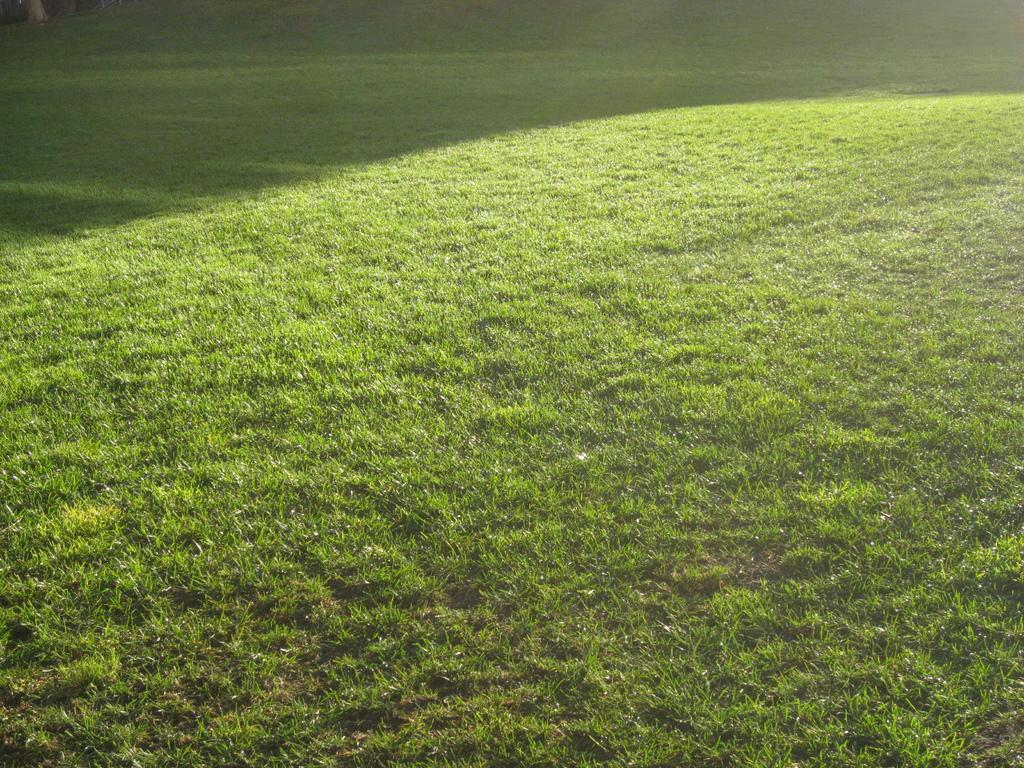What color is the grass in the image? The grass in the image is green. What songs are being played at the party in the image? There is no party or songs present in the image; it only features green grass. 